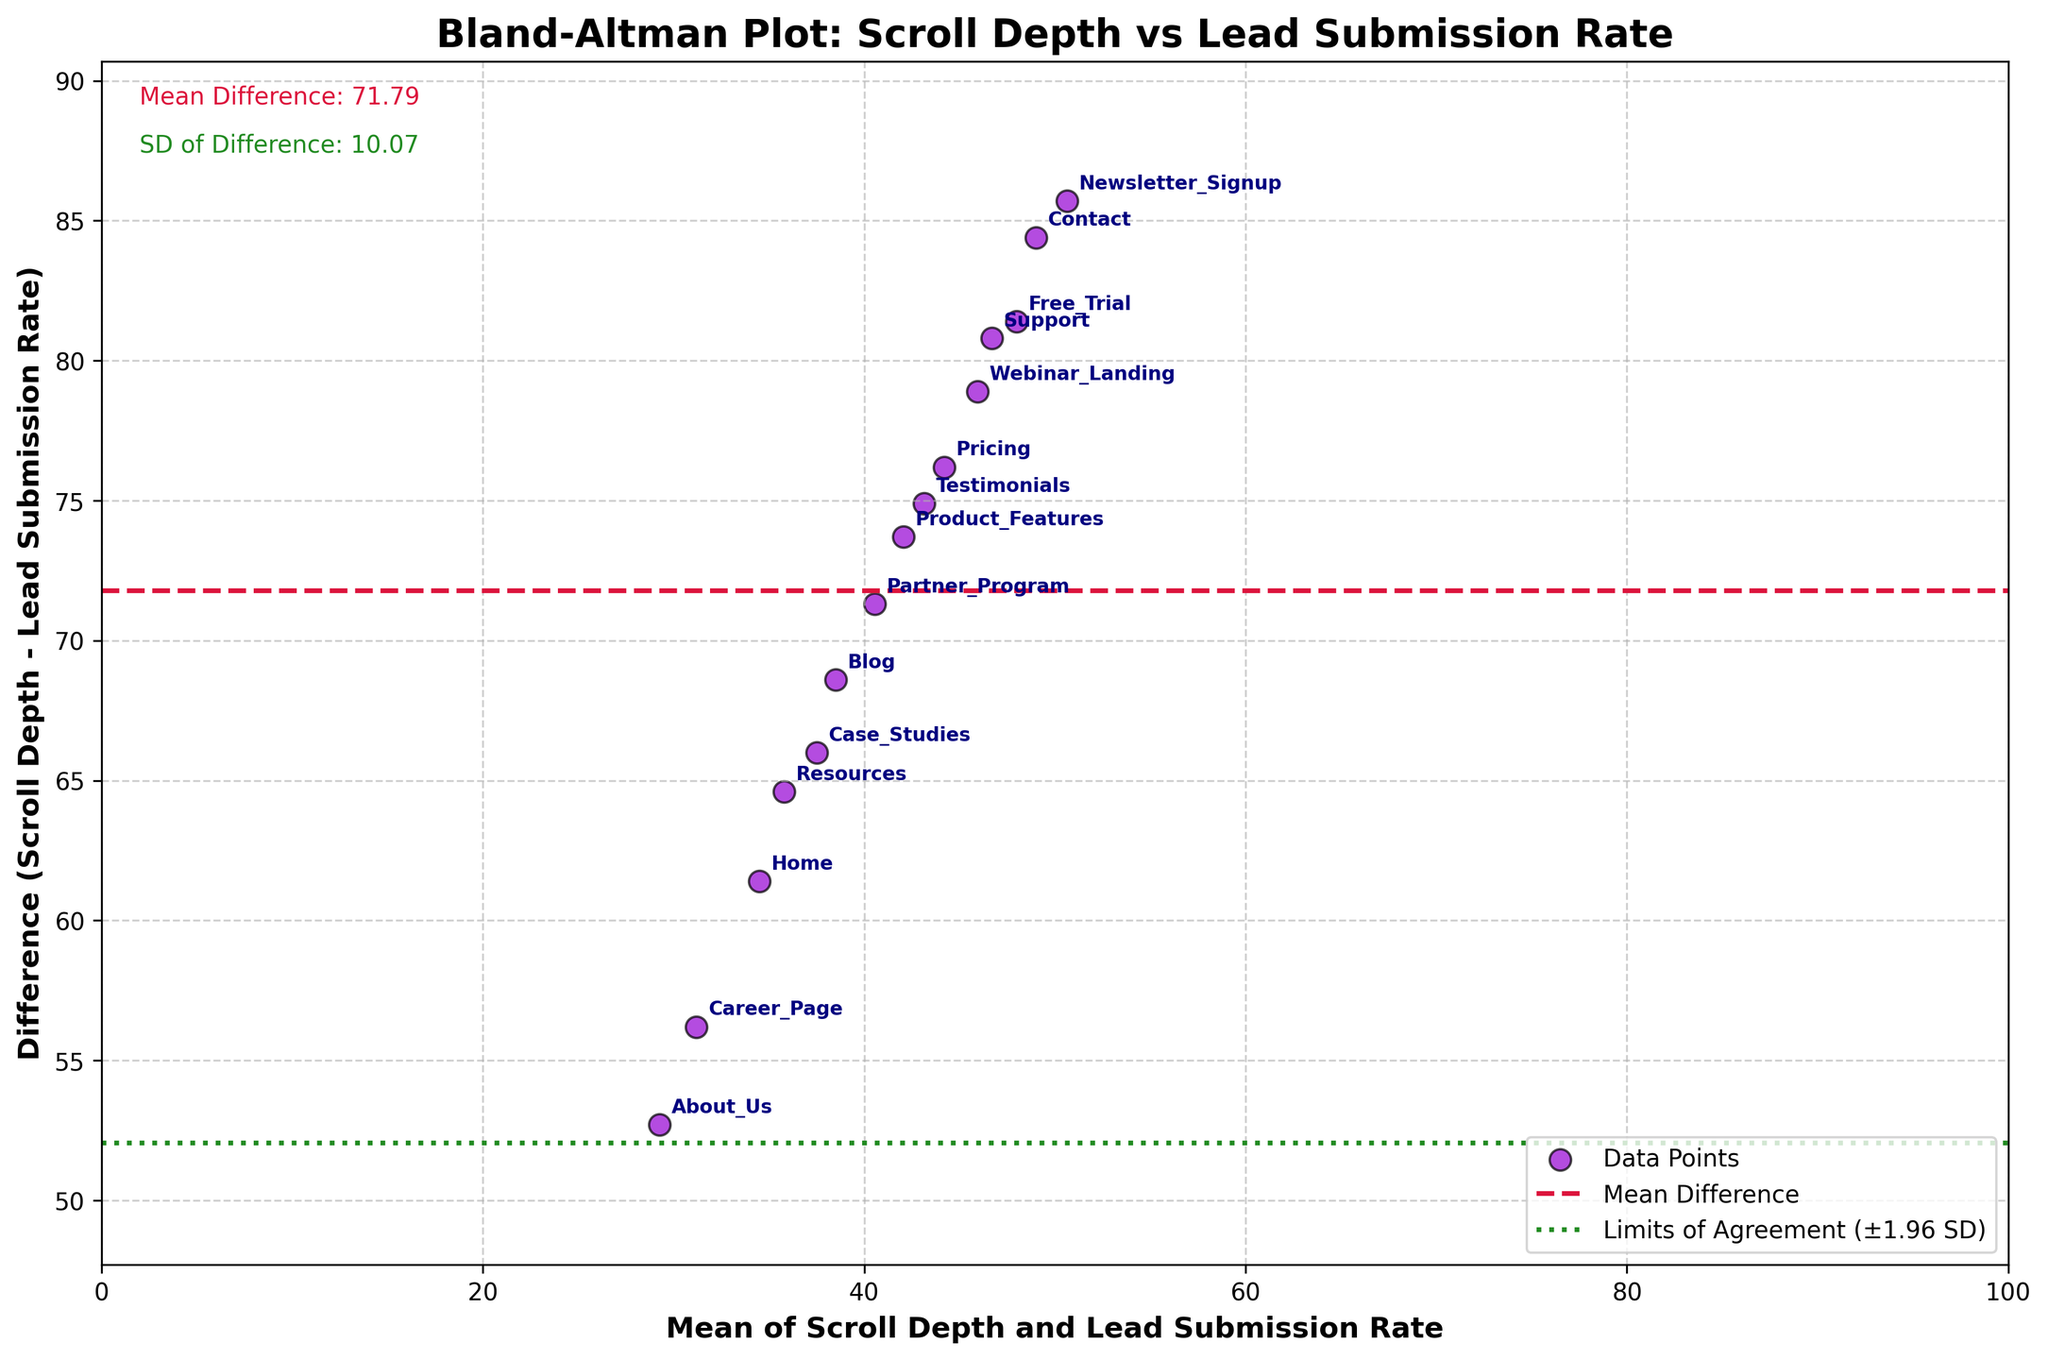what is the title of the plot? The title of the plot is displayed at the top and reads "Bland-Altman Plot: Scroll Depth vs Lead Submission Rate".
Answer: Bland-Altman Plot: Scroll Depth vs Lead Submission Rate Which page has the highest average scroll depth and what is its difference value? Locate the page with the highest value on the x-axis (Average_Scroll_Depth) and then find its corresponding difference value. The page with the highest average scroll depth is "Newsletter_Signup" with a difference value of -2.4.
Answer: Newsletter_Signup, -2.4 What are the limits of agreement in this plot? The limits of agreement are typically shown as horizontal lines above and below the mean difference line, calculated as mean ± 1.96 * standard deviation. The exact positions can be read from the plot. Based on the information provided in the plot, the upper limit is roughly mean_diff + 1.96 * std_diff and the lower limit is roughly mean_diff - 1.96 * std_diff.
Answer: upper limit: ~ 0.25, lower limit: ~ -1.75 What is the mean difference of the plot and what color is the mean difference line? To identify the mean difference, one should look for the central horizontal dashed line and its annotation. This line is typically colored differently for easy identification. Based on the figure description, the mean difference is noted on the plot as "Mean Difference: 0.75" and the line is in crimson color.
Answer: 0.75, crimson Which pages fall outside the limits of agreement? Identify the points that lie outside the horizontal lines representing the limits of agreement. Based on the data and plot, the pages whose data points are beyond the upper or lower bounds are "Newsletter_Signup" and "Free_Trial".
Answer: Newsletter_Signup, Free_Trial Which page has the greatest discrepancy between scroll depth and lead submission rate? The greatest discrepancy is indicated by the highest absolute difference value, represented by the vertical position of the points on the plot. Here, "Newsletter_Signup" shows the greatest negative discrepancy with a difference value of -2.4.
Answer: Newsletter_Signup Are there more points above or below the mean difference line? Count the number of data points plotted above and below the mean difference line. From the figure, there are more points below the mean difference line than above it.
Answer: More points below Which page has the smallest difference value and what is this value? Observe the data point closest to the x-axis and identify the page associated with that point. According to the provided data and plot, "Partner_Program" has the smallest difference value, which is 0.2.
Answer: Partner_Program, 0.2 